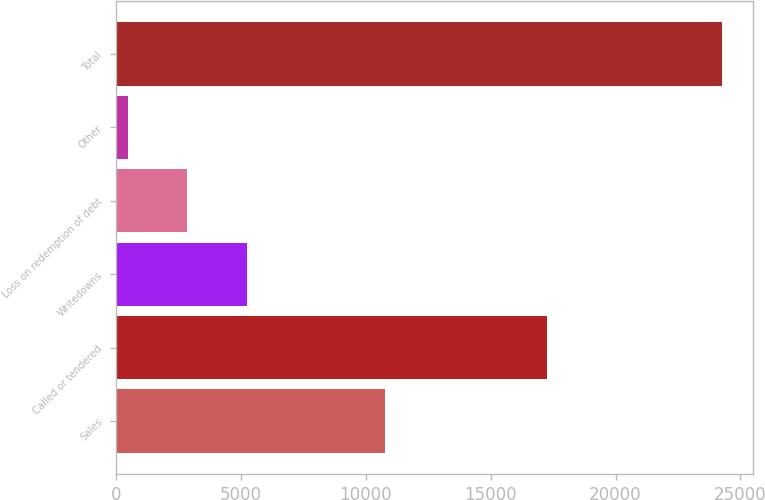Convert chart. <chart><loc_0><loc_0><loc_500><loc_500><bar_chart><fcel>Sales<fcel>Called or tendered<fcel>Writedowns<fcel>Loss on redemption of debt<fcel>Other<fcel>Total<nl><fcel>10761<fcel>17265<fcel>5226.8<fcel>2846.4<fcel>466<fcel>24270<nl></chart> 